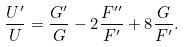Convert formula to latex. <formula><loc_0><loc_0><loc_500><loc_500>\frac { U ^ { \prime } } { U } = \frac { G ^ { \prime } } { G } - 2 \frac { F ^ { \prime \prime } } { F ^ { \prime } } + 8 \frac { G } { F ^ { \prime } } .</formula> 